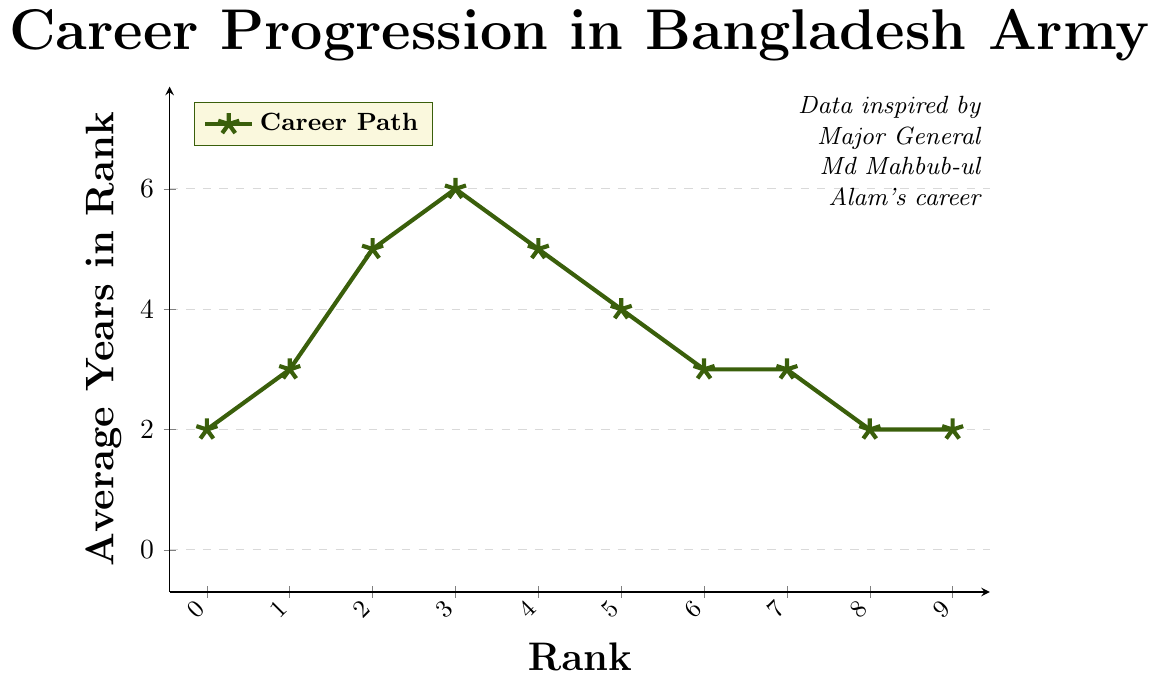what is the total average number of years spent from Second Lieutenant to Major? Sum the average number of years at each rank from Second Lieutenant to Major: 2 + 3 + 5 + 6. So, the total is 16 years.
Answer: 16 Which rank has the highest average number of years served? From the chart, Major has the highest value on the y-axis with 6 years.
Answer: Major How many ranks have an average tenure of 3 years? Identify all ranks with 3 years: Lieutenant, Brigadier General, and Major General. There are three ranks in total.
Answer: 3 What is the average number of years spent from Colonel to General? Sum the average number of years from Colonel to General: 4 + 3 + 3 + 2 + 2. The total is 14 years, and there are 5 ranks, so the average is 14 / 5 = 2.8 years.
Answer: 2.8 Which two ranks have equal average years in rank, and what are they? Brigadier General and Major General both have 3 years.
Answer: Brigadier General, Major General Which ranks have a shorter average tenure than a Major? Identify ranks with an average tenure less than 6 years: Second Lieutenant, Lieutenant, Captain, Lieutenant Colonel, Colonel, Brigadier General, Major General, Lieutenant General, General.
Answer: Second Lieutenant, Lieutenant, Captain, Lieutenant Colonel, Colonel, Brigadier General, Major General, Lieutenant General, General What is the combined average duration spent at both the highest and lowest ranks? The highest is General with 2 years and the lowest is Second Lieutenant with 2 years. Combined, it is 2 + 2 = 4 years.
Answer: 4 How many ranks have an average tenure less than or equal to the average tenure of a Colonel? Colonel has an average tenure of 4 years. Identify ranks with 4 or fewer years: Second Lieutenant, Lieutenant, Lieutenant Colonel, Colonel, Brigadier General, Major General, Lieutenant General, General. There are 8 ranks in total.
Answer: 8 Does the average tenure rise or fall after the rank of Major? After Major (6 years), the tenure generally falls: Lieutenant Colonel (5 years), Colonel (4 years), Brigadier General (3 years), Major General (3 years), Lieutenant General (2 years), General (2 years).
Answer: Falls 